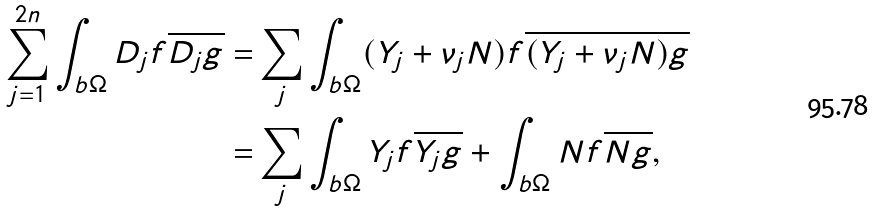<formula> <loc_0><loc_0><loc_500><loc_500>\sum _ { j = 1 } ^ { 2 n } \int _ { b \Omega } D _ { j } f \overline { D _ { j } g } = & \sum _ { j } \int _ { b \Omega } ( Y _ { j } + \nu _ { j } N ) f \overline { ( Y _ { j } + \nu _ { j } N ) g } \\ = & \sum _ { j } \int _ { b \Omega } Y _ { j } f \overline { Y _ { j } g } + \int _ { b \Omega } N f \overline { N g } ,</formula> 